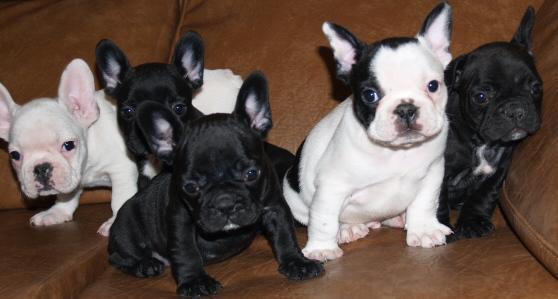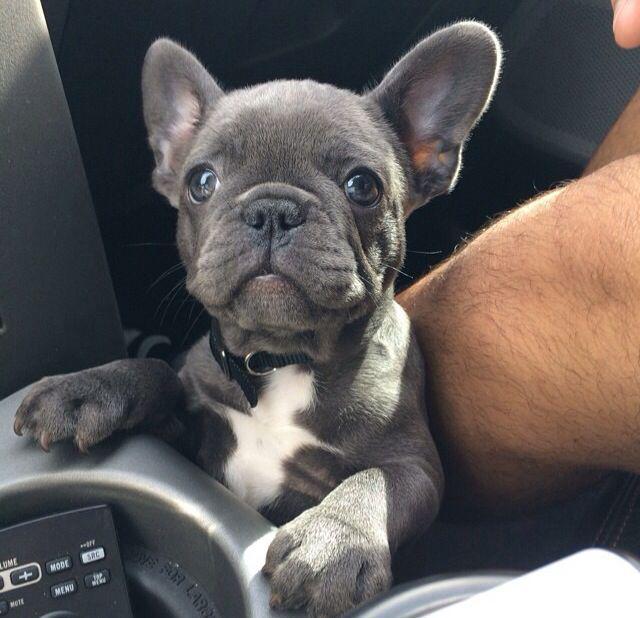The first image is the image on the left, the second image is the image on the right. For the images displayed, is the sentence "There are six dogs" factually correct? Answer yes or no. Yes. The first image is the image on the left, the second image is the image on the right. Evaluate the accuracy of this statement regarding the images: "Exactly six little dogs are shown.". Is it true? Answer yes or no. Yes. 